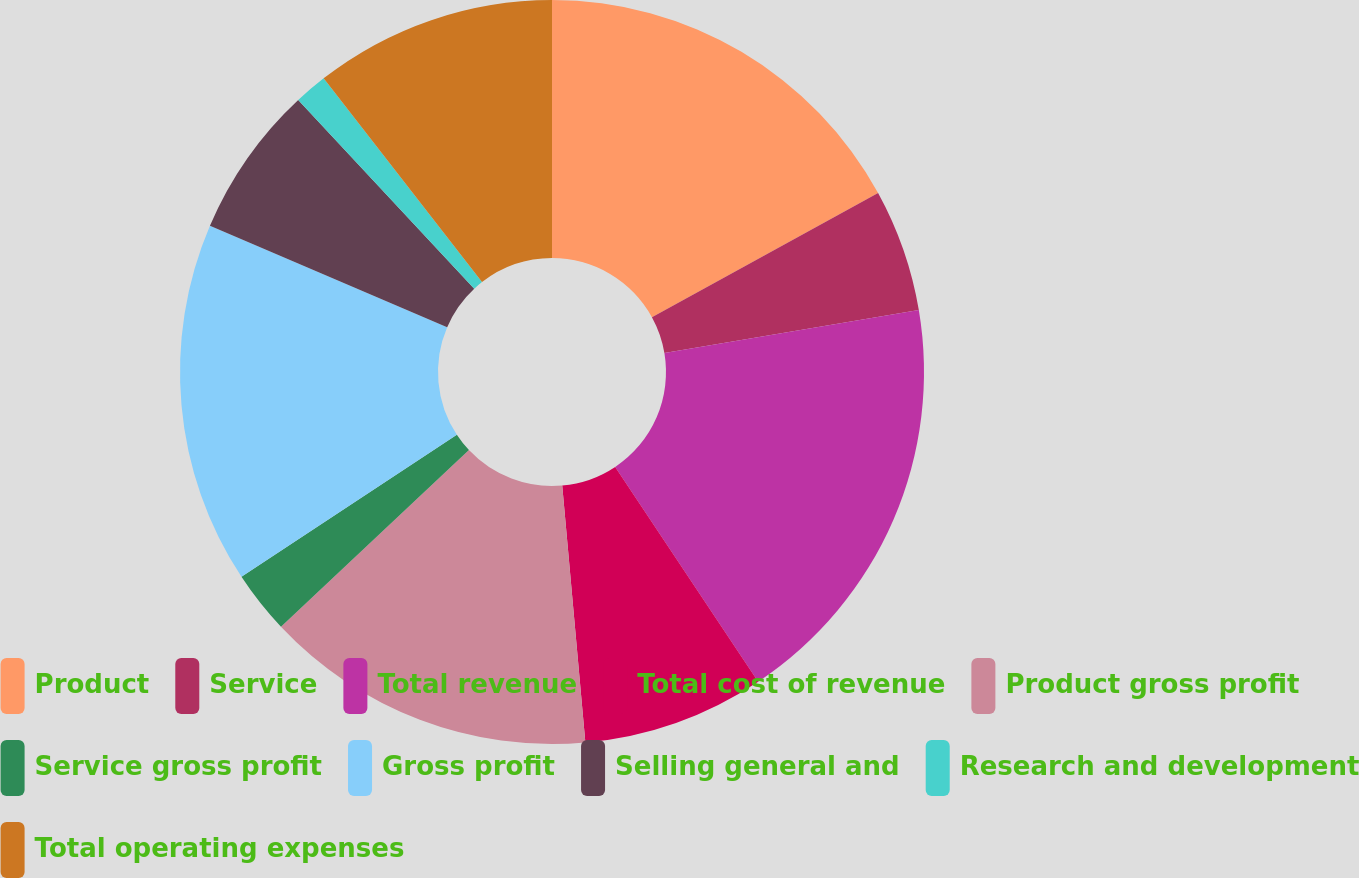<chart> <loc_0><loc_0><loc_500><loc_500><pie_chart><fcel>Product<fcel>Service<fcel>Total revenue<fcel>Total cost of revenue<fcel>Product gross profit<fcel>Service gross profit<fcel>Gross profit<fcel>Selling general and<fcel>Research and development<fcel>Total operating expenses<nl><fcel>17.01%<fcel>5.33%<fcel>18.31%<fcel>7.92%<fcel>14.42%<fcel>2.73%<fcel>15.71%<fcel>6.62%<fcel>1.43%<fcel>10.52%<nl></chart> 